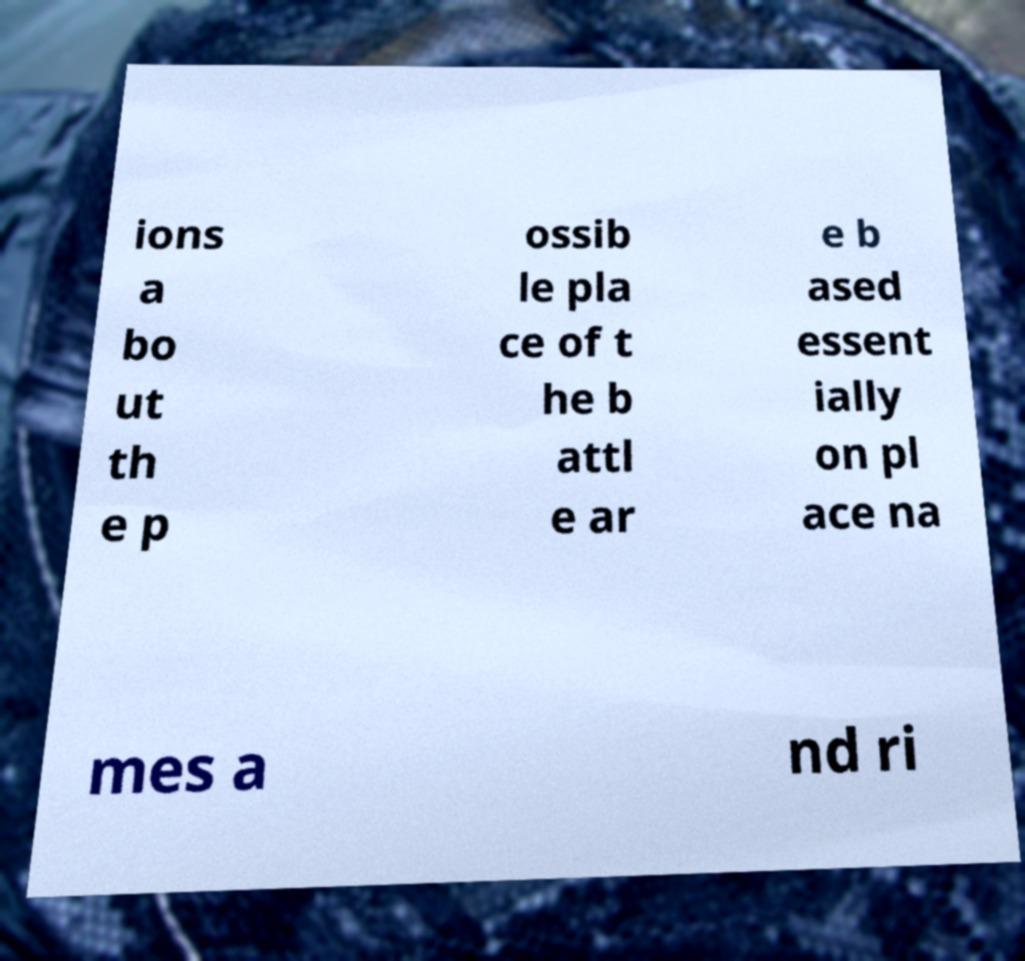Could you assist in decoding the text presented in this image and type it out clearly? ions a bo ut th e p ossib le pla ce of t he b attl e ar e b ased essent ially on pl ace na mes a nd ri 